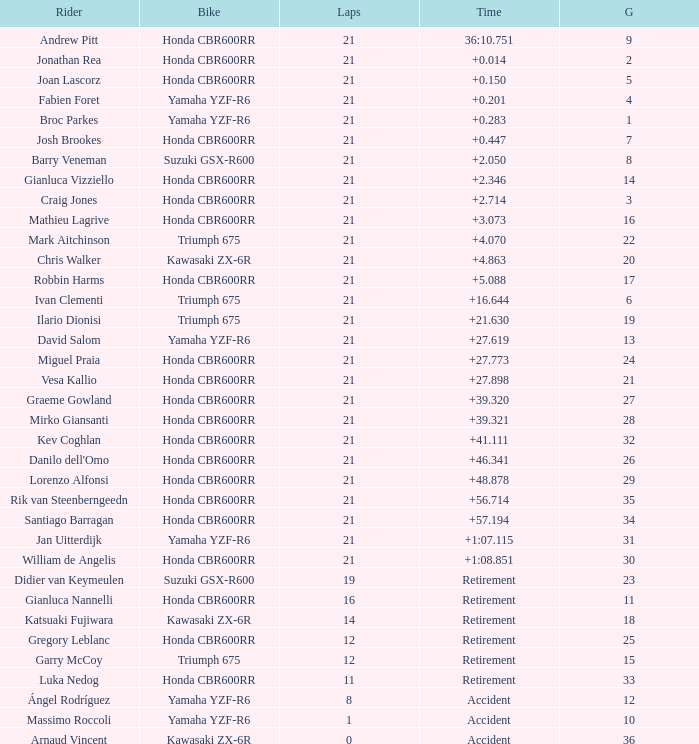Who is the rider with less than 16 laps, started from the 10th position on the grid, rode a yamaha yzf-r6, and had an accident at the end? Massimo Roccoli. 